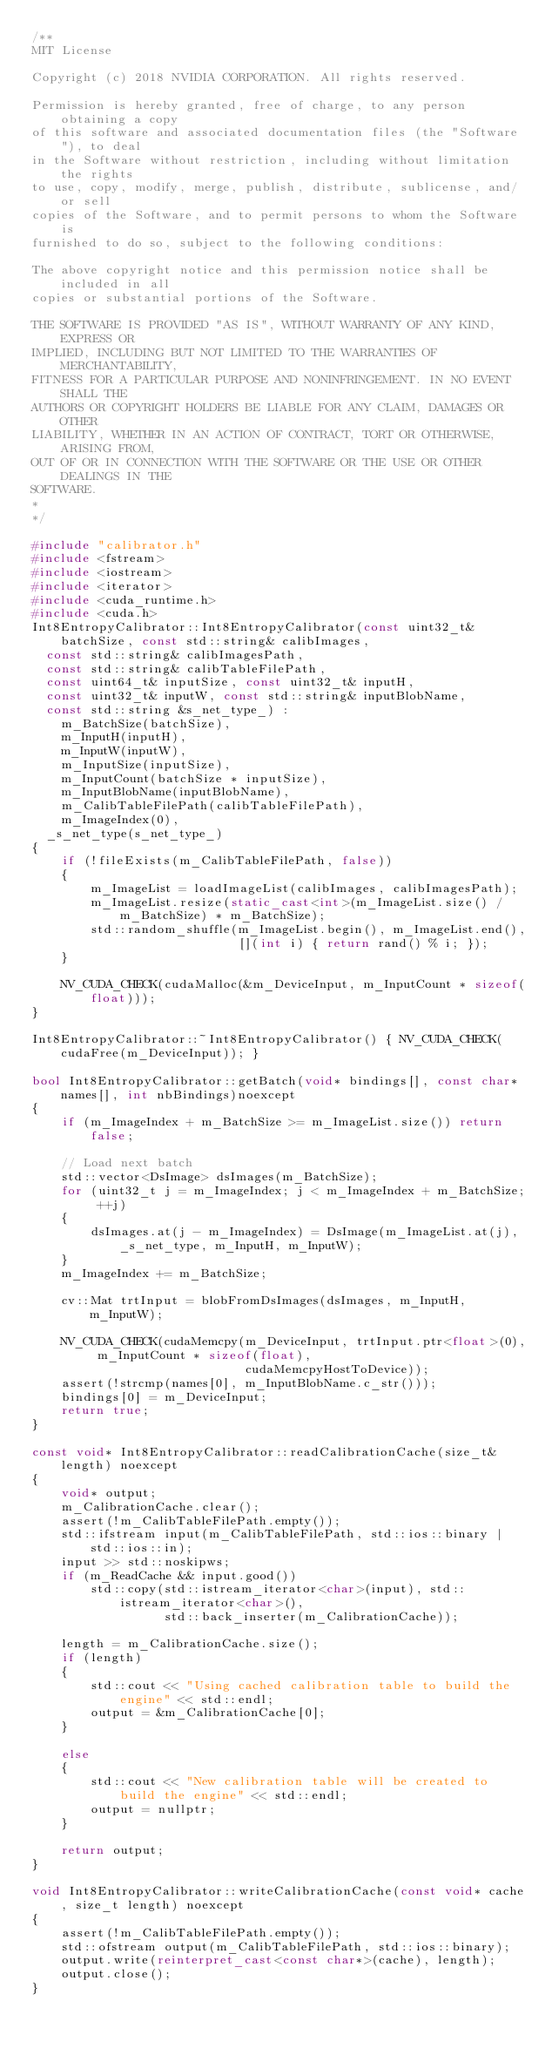Convert code to text. <code><loc_0><loc_0><loc_500><loc_500><_C++_>/**
MIT License

Copyright (c) 2018 NVIDIA CORPORATION. All rights reserved.

Permission is hereby granted, free of charge, to any person obtaining a copy
of this software and associated documentation files (the "Software"), to deal
in the Software without restriction, including without limitation the rights
to use, copy, modify, merge, publish, distribute, sublicense, and/or sell
copies of the Software, and to permit persons to whom the Software is
furnished to do so, subject to the following conditions:

The above copyright notice and this permission notice shall be included in all
copies or substantial portions of the Software.

THE SOFTWARE IS PROVIDED "AS IS", WITHOUT WARRANTY OF ANY KIND, EXPRESS OR
IMPLIED, INCLUDING BUT NOT LIMITED TO THE WARRANTIES OF MERCHANTABILITY,
FITNESS FOR A PARTICULAR PURPOSE AND NONINFRINGEMENT. IN NO EVENT SHALL THE
AUTHORS OR COPYRIGHT HOLDERS BE LIABLE FOR ANY CLAIM, DAMAGES OR OTHER
LIABILITY, WHETHER IN AN ACTION OF CONTRACT, TORT OR OTHERWISE, ARISING FROM,
OUT OF OR IN CONNECTION WITH THE SOFTWARE OR THE USE OR OTHER DEALINGS IN THE
SOFTWARE.
*
*/

#include "calibrator.h"
#include <fstream>
#include <iostream>
#include <iterator>
#include <cuda_runtime.h>
#include <cuda.h>
Int8EntropyCalibrator::Int8EntropyCalibrator(const uint32_t& batchSize, const std::string& calibImages,
	const std::string& calibImagesPath,
	const std::string& calibTableFilePath,
	const uint64_t& inputSize, const uint32_t& inputH,
	const uint32_t& inputW, const std::string& inputBlobName,
	const std::string &s_net_type_) :
    m_BatchSize(batchSize),
    m_InputH(inputH),
    m_InputW(inputW),
    m_InputSize(inputSize),
    m_InputCount(batchSize * inputSize),
    m_InputBlobName(inputBlobName),
    m_CalibTableFilePath(calibTableFilePath),
    m_ImageIndex(0),
	_s_net_type(s_net_type_)
{
    if (!fileExists(m_CalibTableFilePath, false))
    {
        m_ImageList = loadImageList(calibImages, calibImagesPath);
        m_ImageList.resize(static_cast<int>(m_ImageList.size() / m_BatchSize) * m_BatchSize);
        std::random_shuffle(m_ImageList.begin(), m_ImageList.end(),
                            [](int i) { return rand() % i; });
    }

    NV_CUDA_CHECK(cudaMalloc(&m_DeviceInput, m_InputCount * sizeof(float)));
}

Int8EntropyCalibrator::~Int8EntropyCalibrator() { NV_CUDA_CHECK(cudaFree(m_DeviceInput)); }

bool Int8EntropyCalibrator::getBatch(void* bindings[], const char* names[], int nbBindings)noexcept
{
    if (m_ImageIndex + m_BatchSize >= m_ImageList.size()) return false;

    // Load next batch
    std::vector<DsImage> dsImages(m_BatchSize);
    for (uint32_t j = m_ImageIndex; j < m_ImageIndex + m_BatchSize; ++j)
    {
        dsImages.at(j - m_ImageIndex) = DsImage(m_ImageList.at(j), _s_net_type, m_InputH, m_InputW);
    }
    m_ImageIndex += m_BatchSize;

    cv::Mat trtInput = blobFromDsImages(dsImages, m_InputH, m_InputW);

    NV_CUDA_CHECK(cudaMemcpy(m_DeviceInput, trtInput.ptr<float>(0), m_InputCount * sizeof(float),
                             cudaMemcpyHostToDevice));
    assert(!strcmp(names[0], m_InputBlobName.c_str()));
    bindings[0] = m_DeviceInput;
    return true;
}

const void* Int8EntropyCalibrator::readCalibrationCache(size_t& length) noexcept
{
    void* output;
    m_CalibrationCache.clear();
    assert(!m_CalibTableFilePath.empty());
    std::ifstream input(m_CalibTableFilePath, std::ios::binary | std::ios::in);
    input >> std::noskipws;
    if (m_ReadCache && input.good())
        std::copy(std::istream_iterator<char>(input), std::istream_iterator<char>(),
                  std::back_inserter(m_CalibrationCache));

    length = m_CalibrationCache.size();
    if (length)
    {
        std::cout << "Using cached calibration table to build the engine" << std::endl;
        output = &m_CalibrationCache[0];
    }

    else
    {
        std::cout << "New calibration table will be created to build the engine" << std::endl;
        output = nullptr;
    }

    return output;
}

void Int8EntropyCalibrator::writeCalibrationCache(const void* cache, size_t length) noexcept
{
    assert(!m_CalibTableFilePath.empty());
    std::ofstream output(m_CalibTableFilePath, std::ios::binary);
    output.write(reinterpret_cast<const char*>(cache), length);
    output.close();
}</code> 